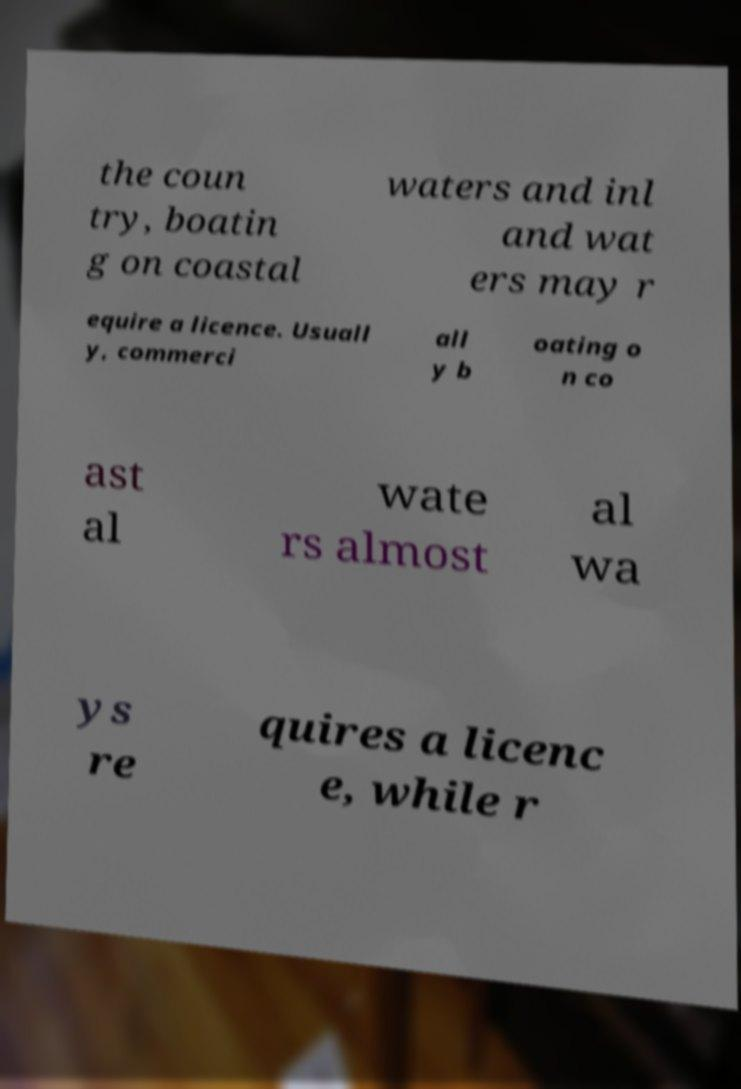I need the written content from this picture converted into text. Can you do that? the coun try, boatin g on coastal waters and inl and wat ers may r equire a licence. Usuall y, commerci all y b oating o n co ast al wate rs almost al wa ys re quires a licenc e, while r 